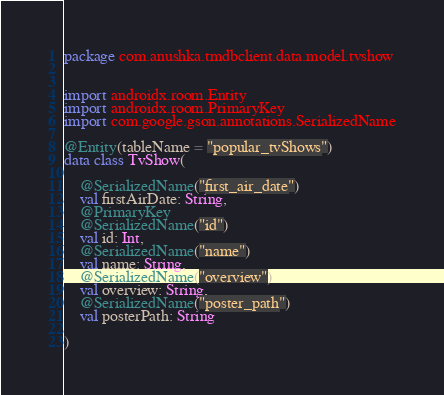<code> <loc_0><loc_0><loc_500><loc_500><_Kotlin_>package com.anushka.tmdbclient.data.model.tvshow


import androidx.room.Entity
import androidx.room.PrimaryKey
import com.google.gson.annotations.SerializedName

@Entity(tableName = "popular_tvShows")
data class TvShow(

    @SerializedName("first_air_date")
    val firstAirDate: String,
    @PrimaryKey
    @SerializedName("id")
    val id: Int,
    @SerializedName("name")
    val name: String,
    @SerializedName("overview")
    val overview: String,
    @SerializedName("poster_path")
    val posterPath: String

)</code> 